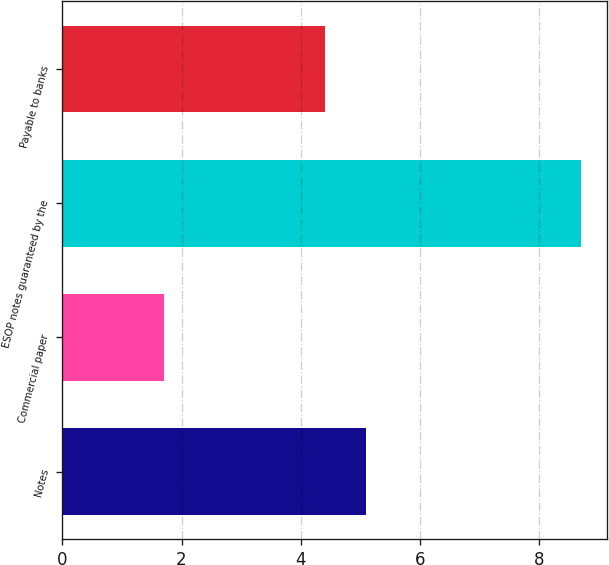<chart> <loc_0><loc_0><loc_500><loc_500><bar_chart><fcel>Notes<fcel>Commercial paper<fcel>ESOP notes guaranteed by the<fcel>Payable to banks<nl><fcel>5.1<fcel>1.7<fcel>8.7<fcel>4.4<nl></chart> 